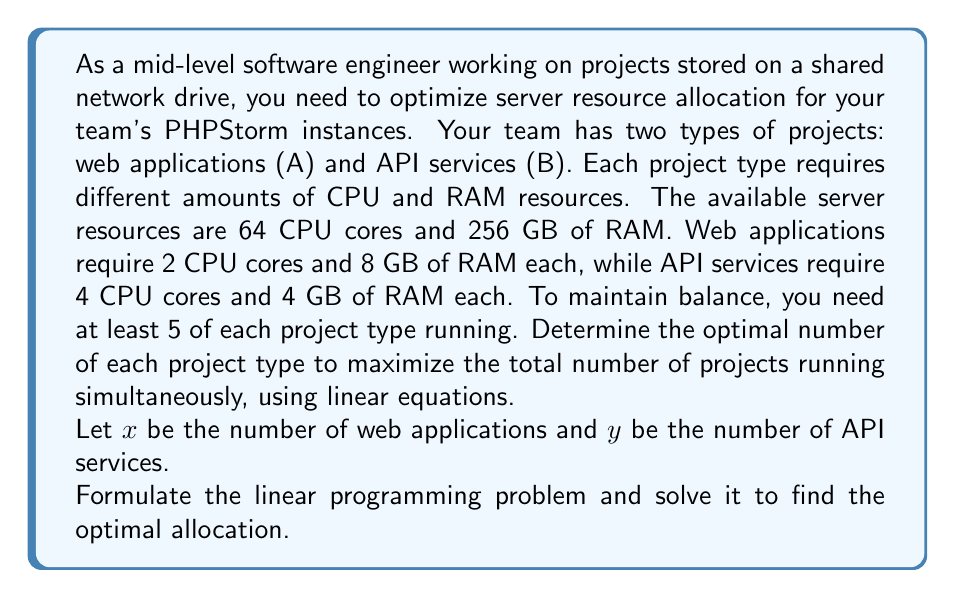Could you help me with this problem? Let's approach this step-by-step:

1. Define the objective function:
   We want to maximize the total number of projects, which is represented by $x + y$.
   Objective function: Maximize $z = x + y$

2. Identify the constraints:
   a) CPU constraint: $2x + 4y \leq 64$
   b) RAM constraint: $8x + 4y \leq 256$
   c) Minimum project requirements: $x \geq 5$ and $y \geq 5$
   d) Non-negativity: $x \geq 0$ and $y \geq 0$ (implied by the previous constraint)

3. Simplify the constraints:
   a) $x + 2y \leq 32$ (CPU)
   b) $2x + y \leq 64$ (RAM)
   c) $x \geq 5$ and $y \geq 5$

4. Graph the constraints:
   [asy]
   size(200);
   import graph;
   
   xaxis("x", 0, 35, Arrow);
   yaxis("y", 0, 35, Arrow);
   
   draw((0,16)--(32,0), blue);
   draw((0,64)--(32,0), red);
   draw((5,5)--(5,35), green);
   draw((5,5)--(35,5), green);
   
   label("CPU: x + 2y = 32", (20,10), blue);
   label("RAM: 2x + y = 64", (15,25), red);
   label("x = 5", (5,20), green);
   label("y = 5", (20,5), green);
   
   dot((5,5));
   dot((21.33,5.33));
   dot((16,16));
   dot((5,13.5));
   
   label("(5, 5)", (5,5), SW);
   label("(21.33, 5.33)", (21.33,5.33), SE);
   label("(16, 16)", (16,16), NE);
   label("(5, 13.5)", (5,13.5), NW);
   [/asy]

5. Identify the feasible region:
   The feasible region is the polygon bounded by the constraints.

6. Find the corner points of the feasible region:
   (5, 5), (21.33, 5.33), (16, 16), (5, 13.5)

7. Evaluate the objective function at each corner point:
   (5, 5): $z = 5 + 5 = 10$
   (21.33, 5.33): $z = 21.33 + 5.33 = 26.66$
   (16, 16): $z = 16 + 16 = 32$
   (5, 13.5): $z = 5 + 13.5 = 18.5$

8. Identify the optimal solution:
   The maximum value of $z$ occurs at the point (16, 16).
Answer: The optimal allocation is 16 web applications (A) and 16 API services (B), for a total of 32 projects running simultaneously. 